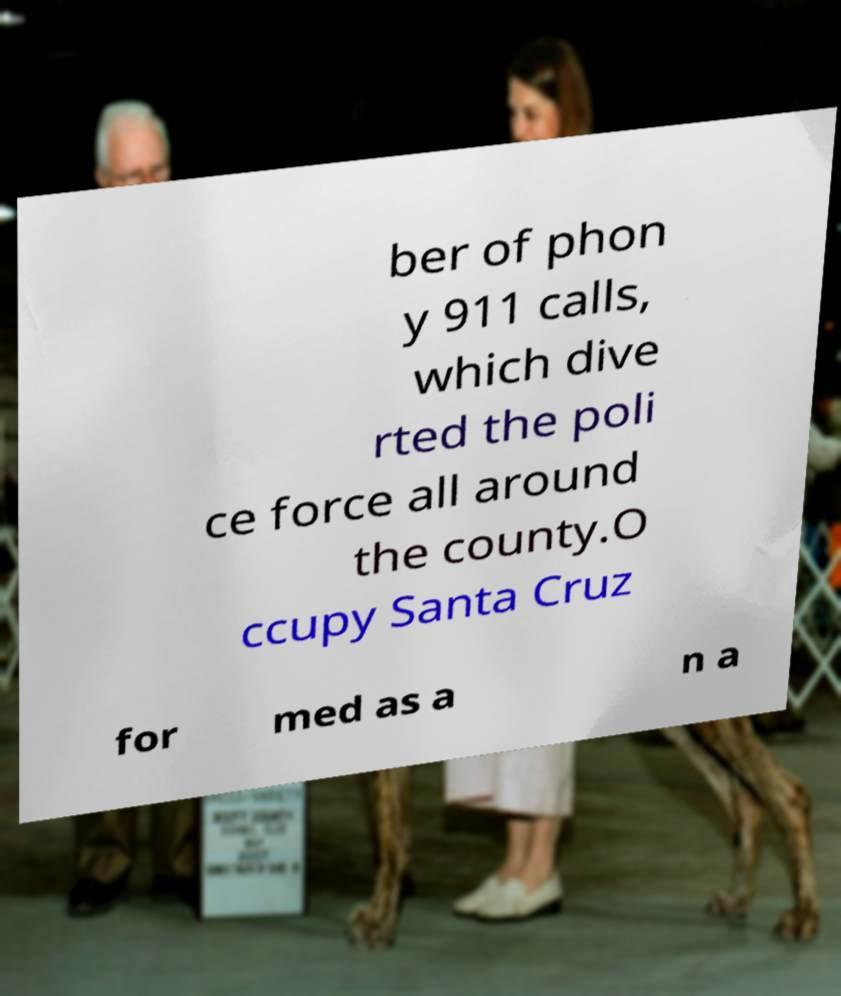There's text embedded in this image that I need extracted. Can you transcribe it verbatim? ber of phon y 911 calls, which dive rted the poli ce force all around the county.O ccupy Santa Cruz for med as a n a 